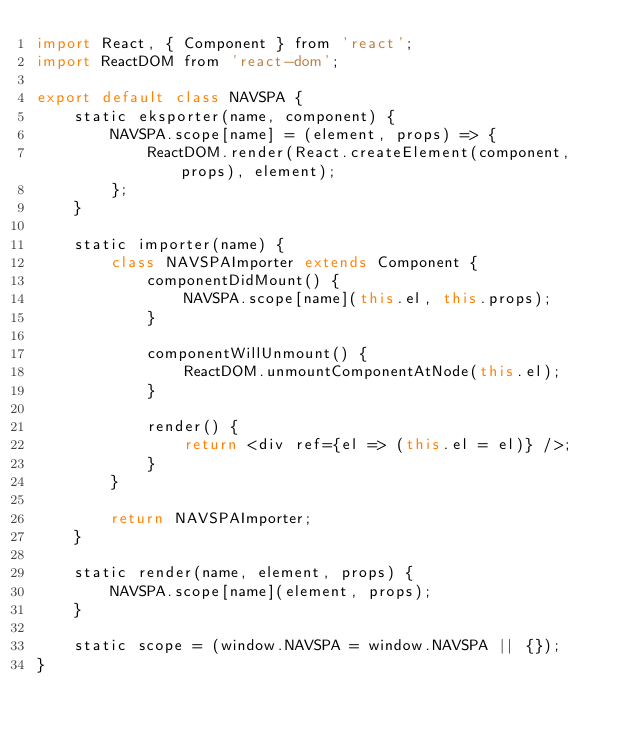Convert code to text. <code><loc_0><loc_0><loc_500><loc_500><_JavaScript_>import React, { Component } from 'react';
import ReactDOM from 'react-dom';

export default class NAVSPA {
    static eksporter(name, component) {
        NAVSPA.scope[name] = (element, props) => {
            ReactDOM.render(React.createElement(component, props), element);
        };
    }

    static importer(name) {
        class NAVSPAImporter extends Component {
            componentDidMount() {
                NAVSPA.scope[name](this.el, this.props);
            }

            componentWillUnmount() {
                ReactDOM.unmountComponentAtNode(this.el);
            }

            render() {
                return <div ref={el => (this.el = el)} />;
            }
        }

        return NAVSPAImporter;
    }

    static render(name, element, props) {
        NAVSPA.scope[name](element, props);
    }

    static scope = (window.NAVSPA = window.NAVSPA || {});
}
</code> 